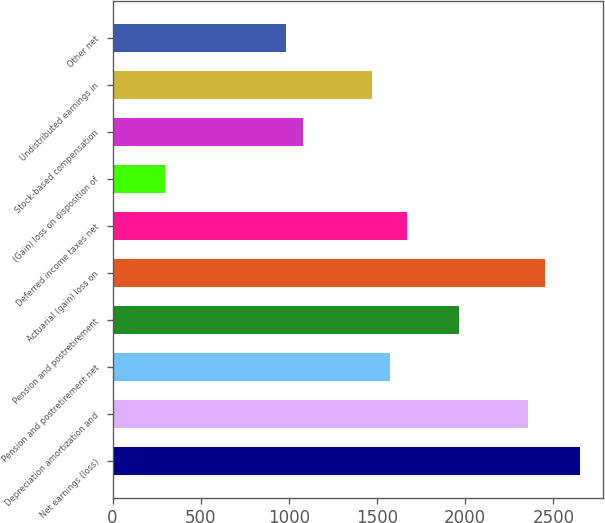Convert chart to OTSL. <chart><loc_0><loc_0><loc_500><loc_500><bar_chart><fcel>Net earnings (loss)<fcel>Depreciation amortization and<fcel>Pension and postretirement net<fcel>Pension and postretirement<fcel>Actuarial (gain) loss on<fcel>Deferred income taxes net<fcel>(Gain) loss on disposition of<fcel>Stock-based compensation<fcel>Undistributed earnings in<fcel>Other net<nl><fcel>2648.3<fcel>2354.6<fcel>1571.4<fcel>1963<fcel>2452.5<fcel>1669.3<fcel>298.7<fcel>1081.9<fcel>1473.5<fcel>984<nl></chart> 